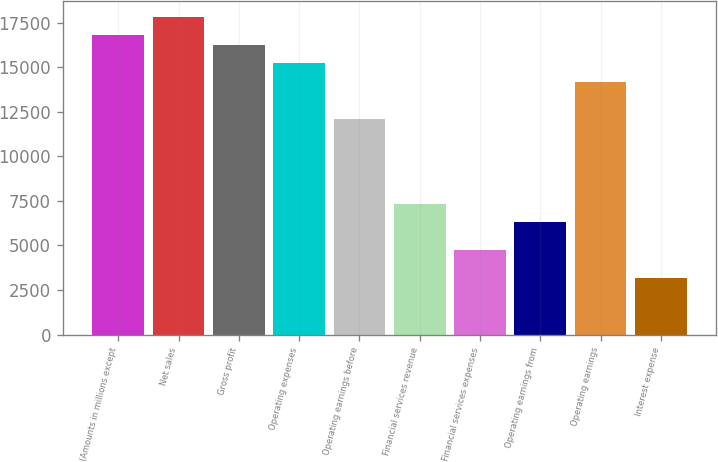Convert chart to OTSL. <chart><loc_0><loc_0><loc_500><loc_500><bar_chart><fcel>(Amounts in millions except<fcel>Net sales<fcel>Gross profit<fcel>Operating expenses<fcel>Operating earnings before<fcel>Financial services revenue<fcel>Financial services expenses<fcel>Operating earnings from<fcel>Operating earnings<fcel>Interest expense<nl><fcel>16794.5<fcel>17844.1<fcel>16269.7<fcel>15220.1<fcel>12071.4<fcel>7348.26<fcel>4724.31<fcel>6298.68<fcel>14170.5<fcel>3149.94<nl></chart> 